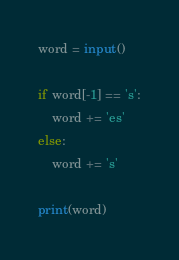Convert code to text. <code><loc_0><loc_0><loc_500><loc_500><_Python_>word = input()

if word[-1] == 's':
    word += 'es'
else:
    word += 's'

print(word)</code> 